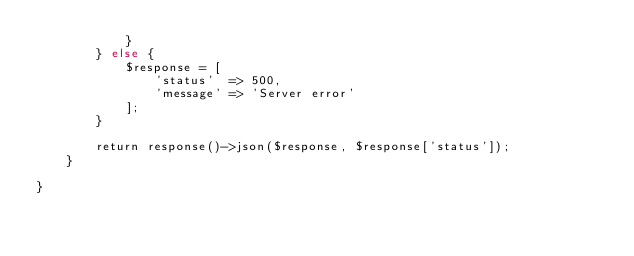Convert code to text. <code><loc_0><loc_0><loc_500><loc_500><_PHP_>            }
        } else {
            $response = [
                'status'  => 500,
                'message' => 'Server error'
            ];
        }

        return response()->json($response, $response['status']);
    }

}
</code> 